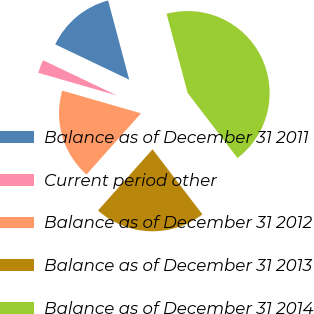<chart> <loc_0><loc_0><loc_500><loc_500><pie_chart><fcel>Balance as of December 31 2011<fcel>Current period other<fcel>Balance as of December 31 2012<fcel>Balance as of December 31 2013<fcel>Balance as of December 31 2014<nl><fcel>13.77%<fcel>2.62%<fcel>17.88%<fcel>21.99%<fcel>43.73%<nl></chart> 